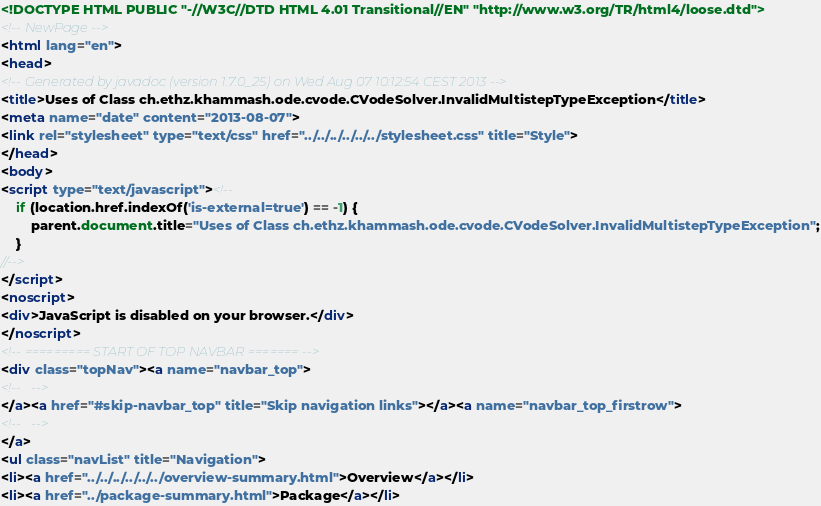Convert code to text. <code><loc_0><loc_0><loc_500><loc_500><_HTML_><!DOCTYPE HTML PUBLIC "-//W3C//DTD HTML 4.01 Transitional//EN" "http://www.w3.org/TR/html4/loose.dtd">
<!-- NewPage -->
<html lang="en">
<head>
<!-- Generated by javadoc (version 1.7.0_25) on Wed Aug 07 10:12:54 CEST 2013 -->
<title>Uses of Class ch.ethz.khammash.ode.cvode.CVodeSolver.InvalidMultistepTypeException</title>
<meta name="date" content="2013-08-07">
<link rel="stylesheet" type="text/css" href="../../../../../../stylesheet.css" title="Style">
</head>
<body>
<script type="text/javascript"><!--
    if (location.href.indexOf('is-external=true') == -1) {
        parent.document.title="Uses of Class ch.ethz.khammash.ode.cvode.CVodeSolver.InvalidMultistepTypeException";
    }
//-->
</script>
<noscript>
<div>JavaScript is disabled on your browser.</div>
</noscript>
<!-- ========= START OF TOP NAVBAR ======= -->
<div class="topNav"><a name="navbar_top">
<!--   -->
</a><a href="#skip-navbar_top" title="Skip navigation links"></a><a name="navbar_top_firstrow">
<!--   -->
</a>
<ul class="navList" title="Navigation">
<li><a href="../../../../../../overview-summary.html">Overview</a></li>
<li><a href="../package-summary.html">Package</a></li></code> 